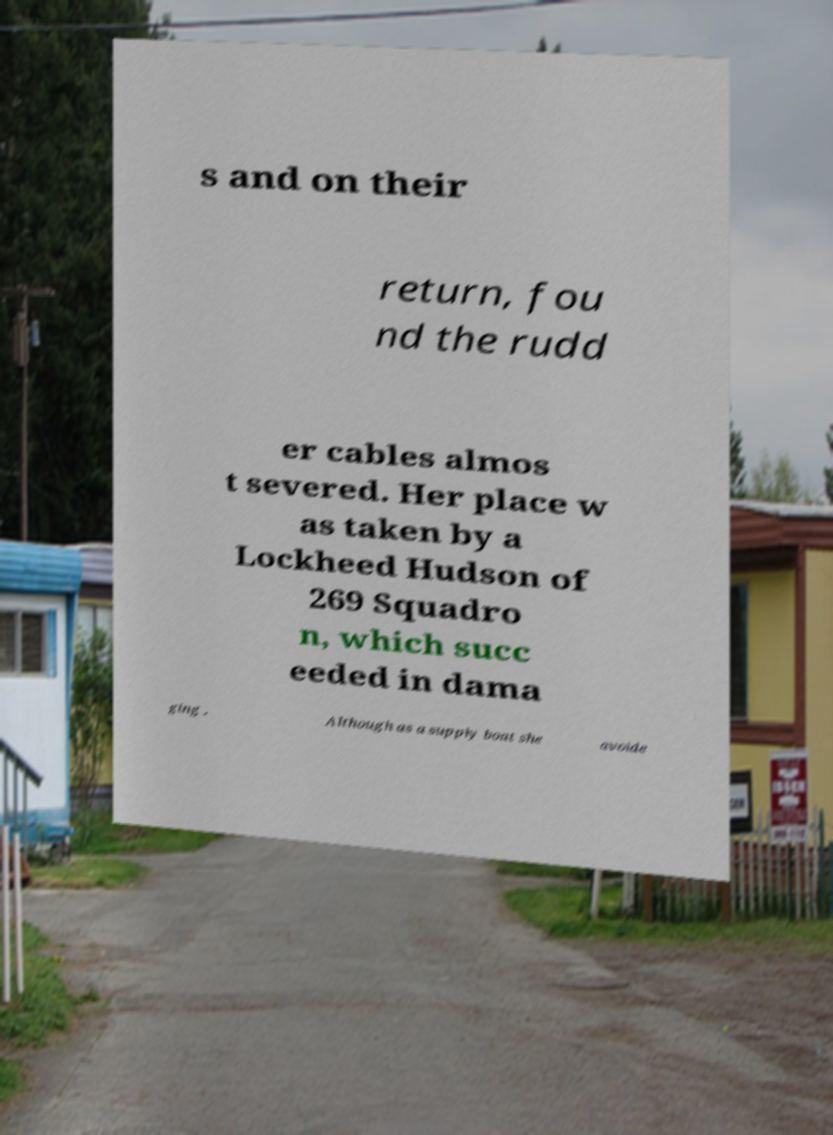For documentation purposes, I need the text within this image transcribed. Could you provide that? s and on their return, fou nd the rudd er cables almos t severed. Her place w as taken by a Lockheed Hudson of 269 Squadro n, which succ eeded in dama ging . Although as a supply boat she avoide 